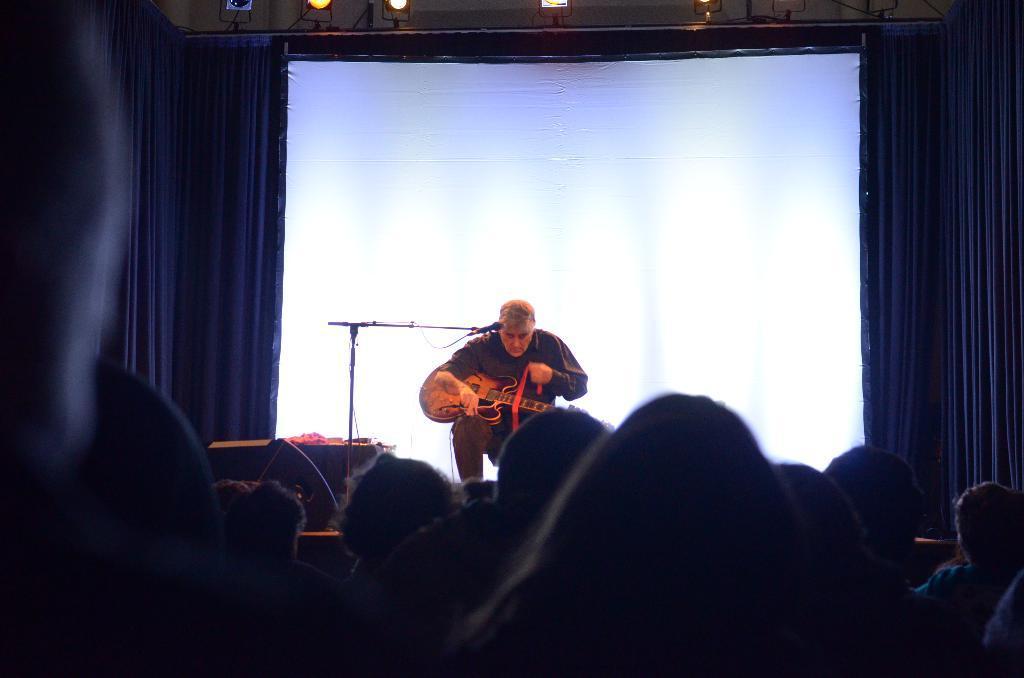How would you summarize this image in a sentence or two? In this image I can see heads of number of persons, the stage, a microphone, a person on the stage who is holding a guitar and a huge screen behind him. In the background I can see the curtains, few lights and few other objects on the stage. 